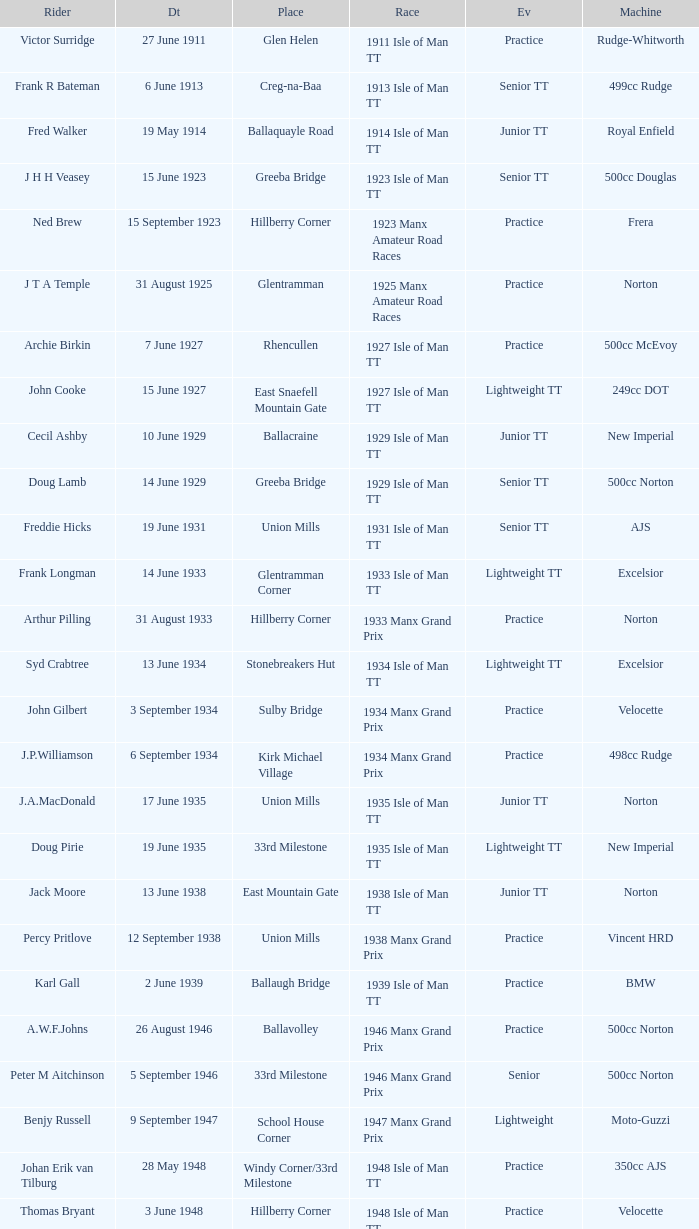What event was Rob Vine riding? Senior TT. 